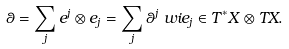<formula> <loc_0><loc_0><loc_500><loc_500>& \theta = \sum _ { j } e ^ { j } \otimes e _ { j } = \sum _ { j } \theta ^ { j } \ w i { e } _ { j } \in T ^ { * } X \otimes T X .</formula> 